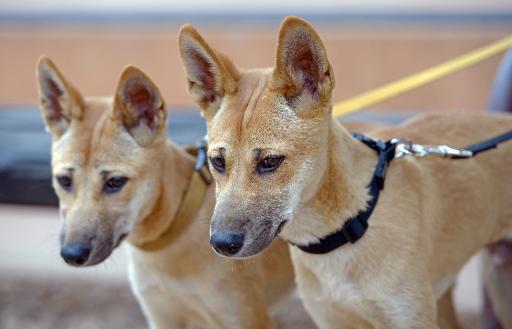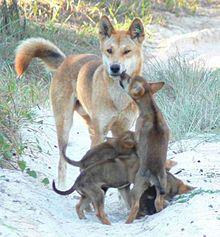The first image is the image on the left, the second image is the image on the right. Evaluate the accuracy of this statement regarding the images: "The same number of canines are shown in the left and right images.". Is it true? Answer yes or no. No. 